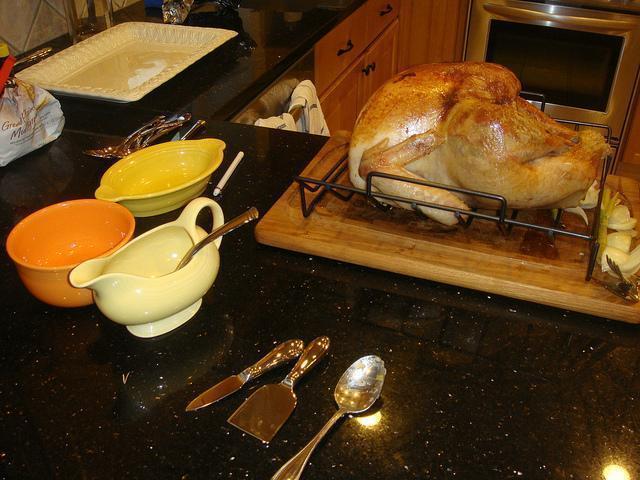What type of animal is being prepared?
Select the accurate answer and provide explanation: 'Answer: answer
Rationale: rationale.'
Options: Cat, bird, dog, horse. Answer: bird.
Rationale: It has wings, legs and a breast. 